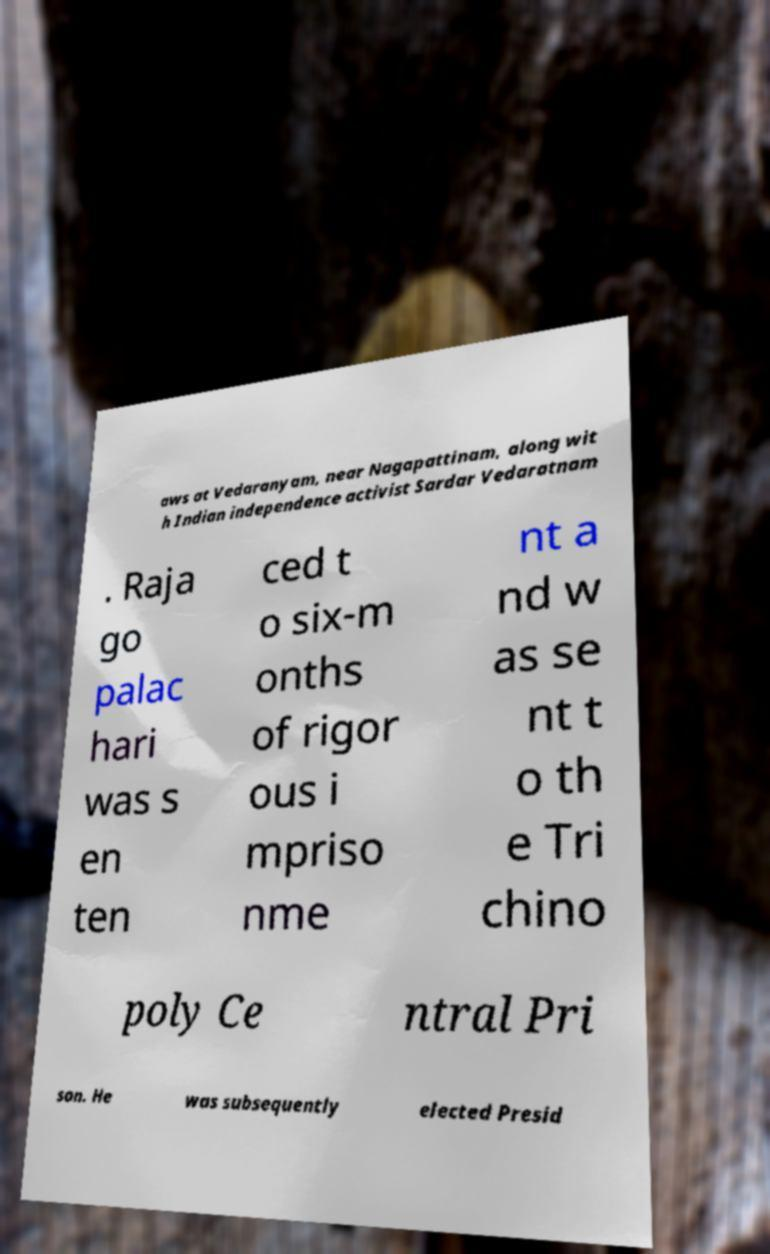For documentation purposes, I need the text within this image transcribed. Could you provide that? aws at Vedaranyam, near Nagapattinam, along wit h Indian independence activist Sardar Vedaratnam . Raja go palac hari was s en ten ced t o six-m onths of rigor ous i mpriso nme nt a nd w as se nt t o th e Tri chino poly Ce ntral Pri son. He was subsequently elected Presid 